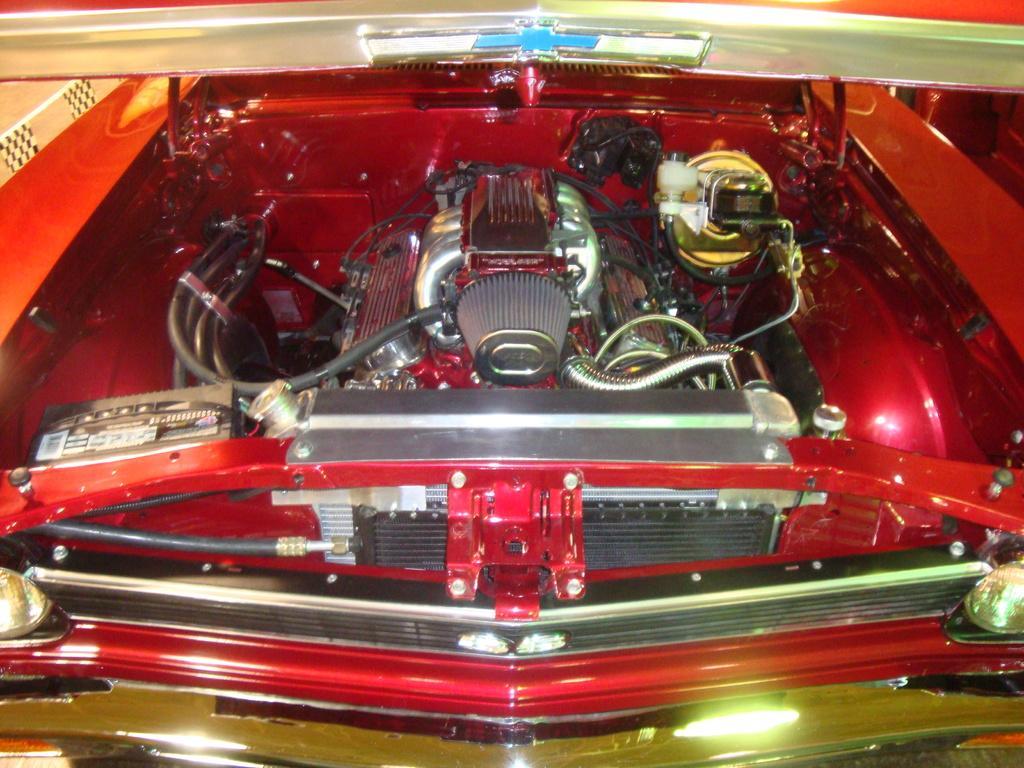In one or two sentences, can you explain what this image depicts? In this image I can see a red colored vehicle and the engine of the vehicle which is silver, red, black and gold in color. To the top of the image I can see the blue colored logo. 